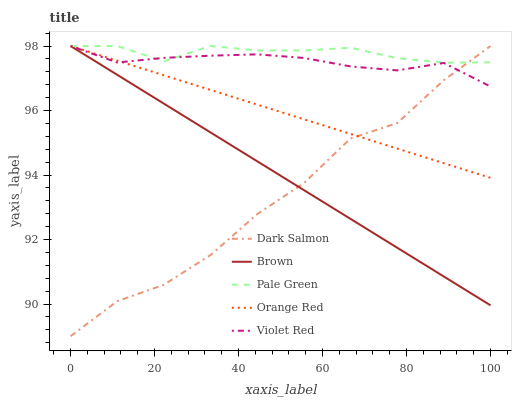Does Dark Salmon have the minimum area under the curve?
Answer yes or no. Yes. Does Pale Green have the maximum area under the curve?
Answer yes or no. Yes. Does Violet Red have the minimum area under the curve?
Answer yes or no. No. Does Violet Red have the maximum area under the curve?
Answer yes or no. No. Is Orange Red the smoothest?
Answer yes or no. Yes. Is Dark Salmon the roughest?
Answer yes or no. Yes. Is Violet Red the smoothest?
Answer yes or no. No. Is Violet Red the roughest?
Answer yes or no. No. Does Dark Salmon have the lowest value?
Answer yes or no. Yes. Does Violet Red have the lowest value?
Answer yes or no. No. Does Orange Red have the highest value?
Answer yes or no. Yes. Does Dark Salmon intersect Violet Red?
Answer yes or no. Yes. Is Dark Salmon less than Violet Red?
Answer yes or no. No. Is Dark Salmon greater than Violet Red?
Answer yes or no. No. 